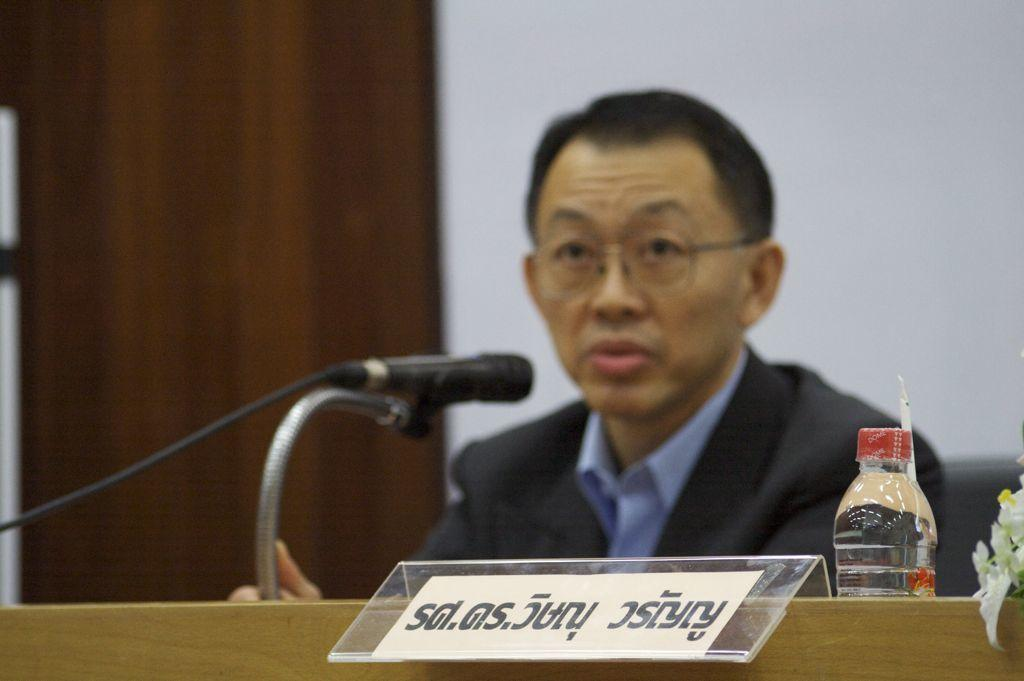Who is present in the image? There is a person in the image. What is the person doing in the image? The person is sitting on a chair and speaking on a microphone. What is the person wearing in the image? The person is wearing a suit in the image. What type of breakfast is the person eating in the image? There is no breakfast present in the image; the person is sitting on a chair and speaking on a microphone. How many hands does the person have in the image? The number of hands the person has cannot be determined from the image, as only one hand is visible while holding the microphone. 